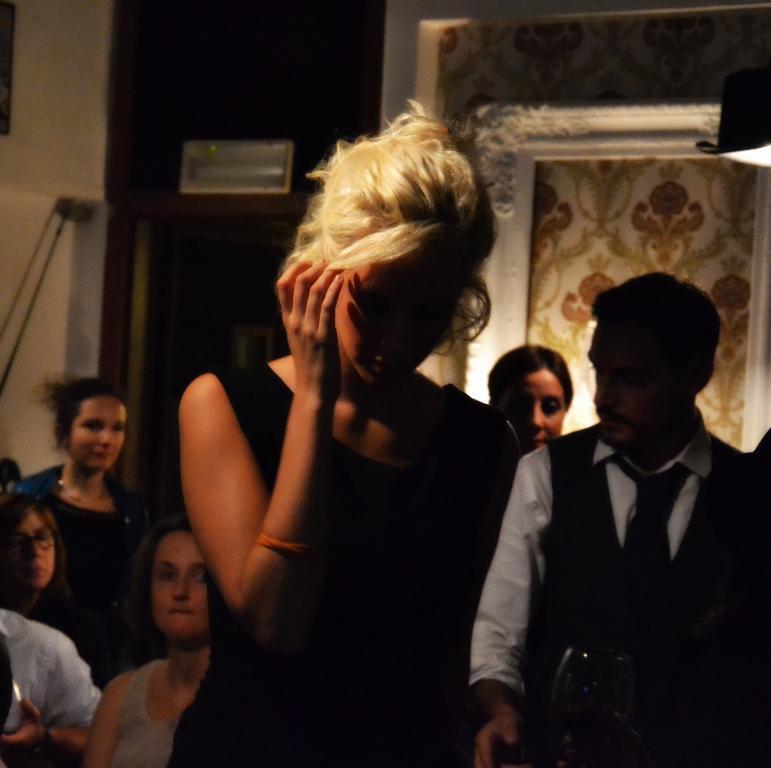Please provide a concise description of this image. In this image, we can see people and in the background, there is a board, stand, a wall and we can see another object. 